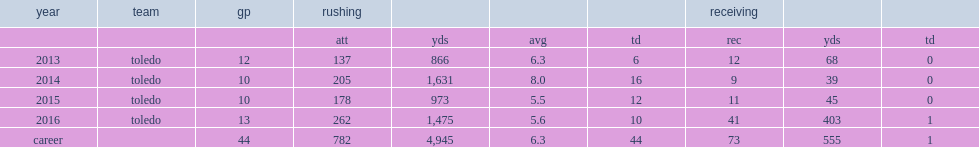In 2016, how many rushing attempts did hunt play 13 games with? 262.0. In 2016, how many yards did hunt play 13 games with? 1475.0. 